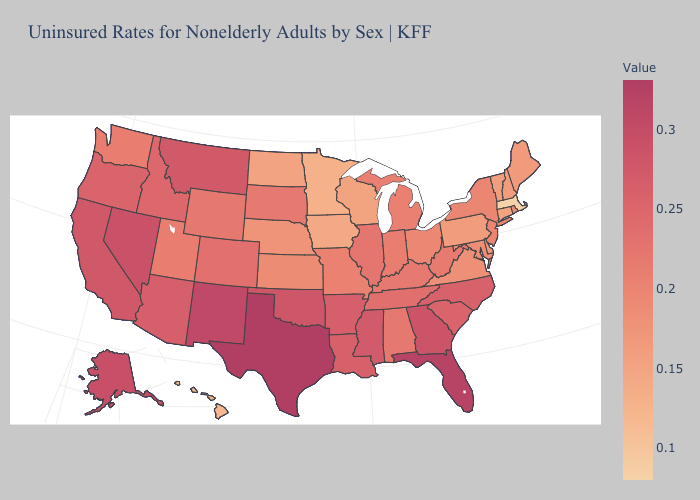Does the map have missing data?
Short answer required. No. Among the states that border Mississippi , which have the lowest value?
Short answer required. Alabama. Among the states that border Texas , which have the lowest value?
Answer briefly. Louisiana. Which states hav the highest value in the MidWest?
Short answer required. Illinois. Is the legend a continuous bar?
Be succinct. Yes. 